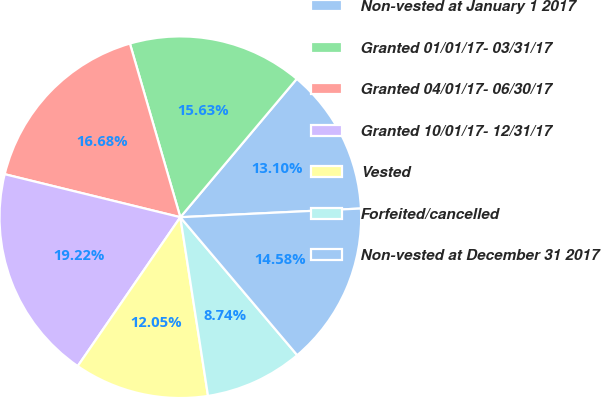<chart> <loc_0><loc_0><loc_500><loc_500><pie_chart><fcel>Non-vested at January 1 2017<fcel>Granted 01/01/17- 03/31/17<fcel>Granted 04/01/17- 06/30/17<fcel>Granted 10/01/17- 12/31/17<fcel>Vested<fcel>Forfeited/cancelled<fcel>Non-vested at December 31 2017<nl><fcel>13.1%<fcel>15.63%<fcel>16.68%<fcel>19.22%<fcel>12.05%<fcel>8.74%<fcel>14.58%<nl></chart> 